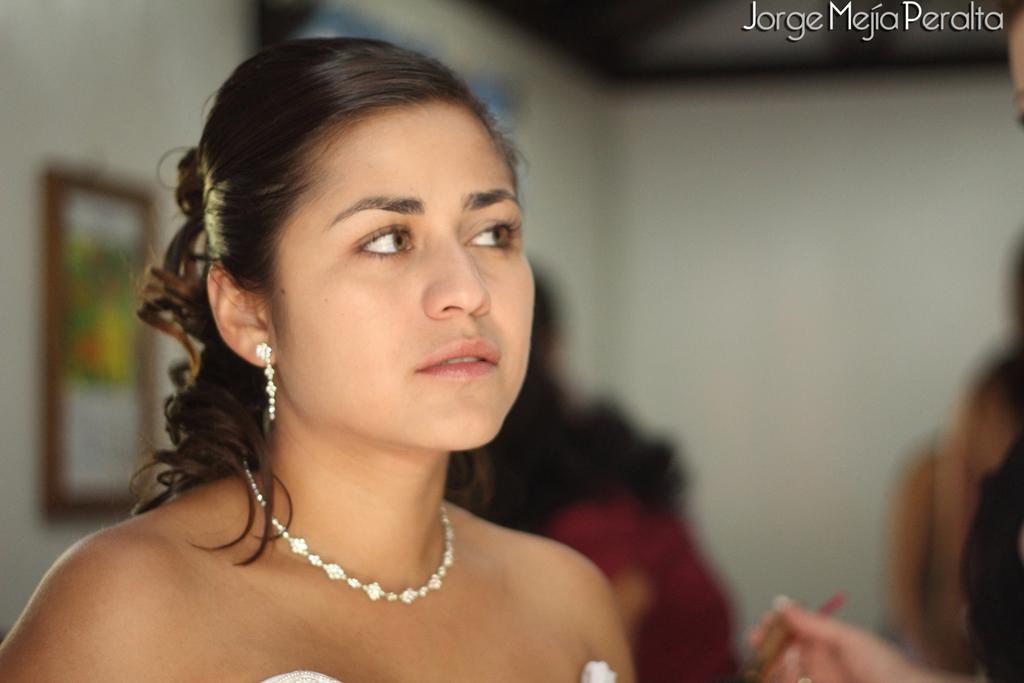Could you give a brief overview of what you see in this image? In this picture I can observe a woman. There is a necklace in her neck. The background is blurred. In the top right side I can observe text in this picture. 